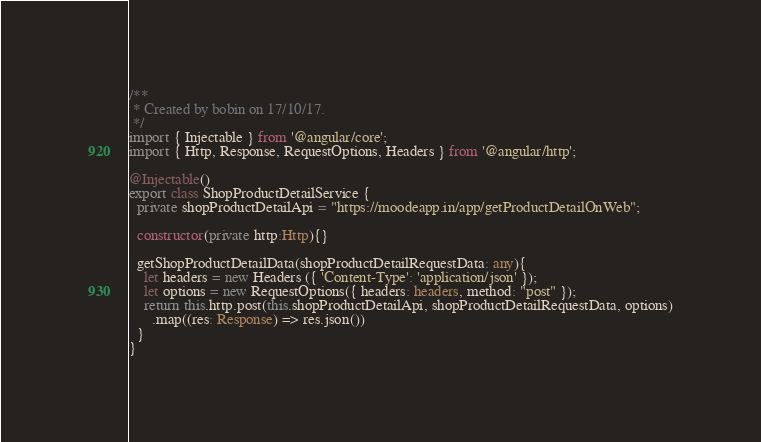<code> <loc_0><loc_0><loc_500><loc_500><_TypeScript_>/**
 * Created by bobin on 17/10/17.
 */
import { Injectable } from '@angular/core';
import { Http, Response, RequestOptions, Headers } from '@angular/http';

@Injectable()
export class ShopProductDetailService {
  private shopProductDetailApi = "https://moodeapp.in/app/getProductDetailOnWeb";

  constructor(private http:Http){}

  getShopProductDetailData(shopProductDetailRequestData: any){
    let headers = new Headers ({ 'Content-Type': 'application/json' });
    let options = new RequestOptions({ headers: headers, method: "post" });
    return this.http.post(this.shopProductDetailApi, shopProductDetailRequestData, options)
      .map((res: Response) => res.json())
  }
}
</code> 